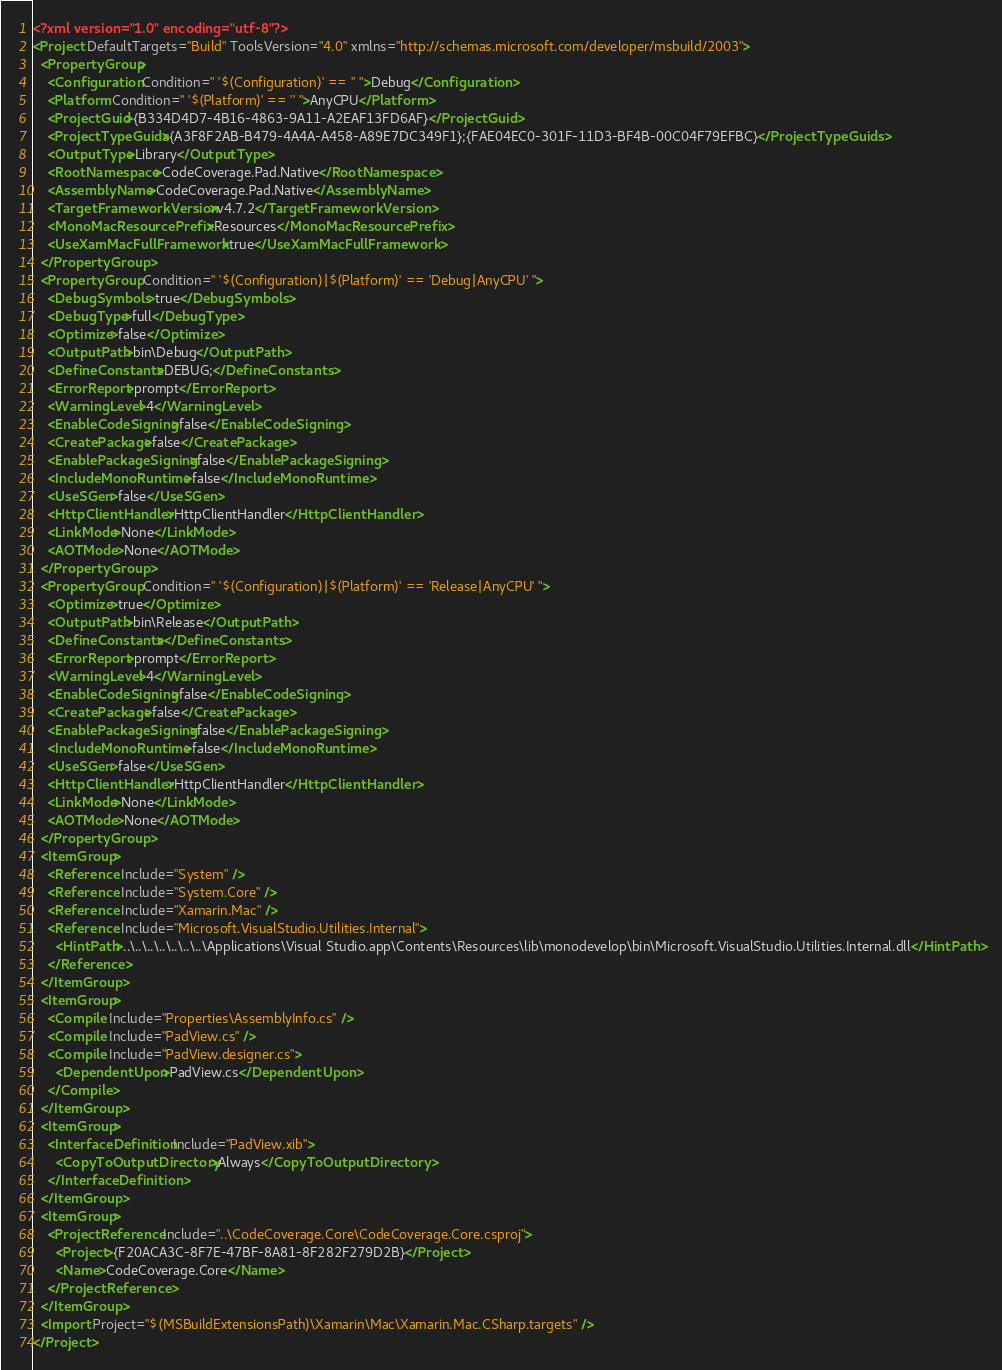Convert code to text. <code><loc_0><loc_0><loc_500><loc_500><_XML_><?xml version="1.0" encoding="utf-8"?>
<Project DefaultTargets="Build" ToolsVersion="4.0" xmlns="http://schemas.microsoft.com/developer/msbuild/2003">
  <PropertyGroup>
    <Configuration Condition=" '$(Configuration)' == '' ">Debug</Configuration>
    <Platform Condition=" '$(Platform)' == '' ">AnyCPU</Platform>
    <ProjectGuid>{B334D4D7-4B16-4863-9A11-A2EAF13FD6AF}</ProjectGuid>
    <ProjectTypeGuids>{A3F8F2AB-B479-4A4A-A458-A89E7DC349F1};{FAE04EC0-301F-11D3-BF4B-00C04F79EFBC}</ProjectTypeGuids>
    <OutputType>Library</OutputType>
    <RootNamespace>CodeCoverage.Pad.Native</RootNamespace>
    <AssemblyName>CodeCoverage.Pad.Native</AssemblyName>
    <TargetFrameworkVersion>v4.7.2</TargetFrameworkVersion>
    <MonoMacResourcePrefix>Resources</MonoMacResourcePrefix>
    <UseXamMacFullFramework>true</UseXamMacFullFramework>
  </PropertyGroup>
  <PropertyGroup Condition=" '$(Configuration)|$(Platform)' == 'Debug|AnyCPU' ">
    <DebugSymbols>true</DebugSymbols>
    <DebugType>full</DebugType>
    <Optimize>false</Optimize>
    <OutputPath>bin\Debug</OutputPath>
    <DefineConstants>DEBUG;</DefineConstants>
    <ErrorReport>prompt</ErrorReport>
    <WarningLevel>4</WarningLevel>
    <EnableCodeSigning>false</EnableCodeSigning>
    <CreatePackage>false</CreatePackage>
    <EnablePackageSigning>false</EnablePackageSigning>
    <IncludeMonoRuntime>false</IncludeMonoRuntime>
    <UseSGen>false</UseSGen>
    <HttpClientHandler>HttpClientHandler</HttpClientHandler>
    <LinkMode>None</LinkMode>
    <AOTMode>None</AOTMode>
  </PropertyGroup>
  <PropertyGroup Condition=" '$(Configuration)|$(Platform)' == 'Release|AnyCPU' ">
    <Optimize>true</Optimize>
    <OutputPath>bin\Release</OutputPath>
    <DefineConstants></DefineConstants>
    <ErrorReport>prompt</ErrorReport>
    <WarningLevel>4</WarningLevel>
    <EnableCodeSigning>false</EnableCodeSigning>
    <CreatePackage>false</CreatePackage>
    <EnablePackageSigning>false</EnablePackageSigning>
    <IncludeMonoRuntime>false</IncludeMonoRuntime>
    <UseSGen>false</UseSGen>
    <HttpClientHandler>HttpClientHandler</HttpClientHandler>
    <LinkMode>None</LinkMode>
    <AOTMode>None</AOTMode>
  </PropertyGroup>
  <ItemGroup>
    <Reference Include="System" />
    <Reference Include="System.Core" />
    <Reference Include="Xamarin.Mac" />
    <Reference Include="Microsoft.VisualStudio.Utilities.Internal">
      <HintPath>..\..\..\..\..\..\..\Applications\Visual Studio.app\Contents\Resources\lib\monodevelop\bin\Microsoft.VisualStudio.Utilities.Internal.dll</HintPath>
    </Reference>
  </ItemGroup>
  <ItemGroup>
    <Compile Include="Properties\AssemblyInfo.cs" />
    <Compile Include="PadView.cs" />
    <Compile Include="PadView.designer.cs">
      <DependentUpon>PadView.cs</DependentUpon>
    </Compile>
  </ItemGroup>
  <ItemGroup>
    <InterfaceDefinition Include="PadView.xib">
      <CopyToOutputDirectory>Always</CopyToOutputDirectory>
    </InterfaceDefinition>
  </ItemGroup>
  <ItemGroup>
    <ProjectReference Include="..\CodeCoverage.Core\CodeCoverage.Core.csproj">
      <Project>{F20ACA3C-8F7E-47BF-8A81-8F282F279D2B}</Project>
      <Name>CodeCoverage.Core</Name>
    </ProjectReference>
  </ItemGroup>
  <Import Project="$(MSBuildExtensionsPath)\Xamarin\Mac\Xamarin.Mac.CSharp.targets" />
</Project></code> 